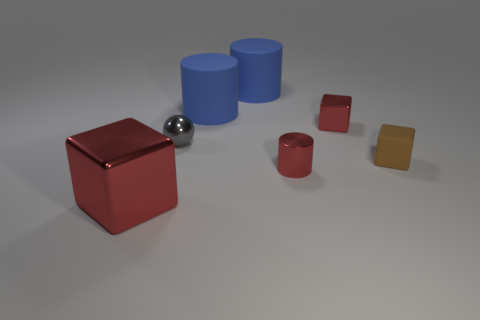Are there fewer red cubes that are in front of the tiny brown block than yellow metallic objects?
Provide a short and direct response. No. How big is the cylinder in front of the red object behind the small block in front of the tiny red metallic cube?
Provide a short and direct response. Small. Is the material of the red cylinder to the left of the matte cube the same as the small gray object?
Offer a terse response. Yes. There is a large cube that is the same color as the tiny metallic cube; what is its material?
Provide a succinct answer. Metal. Is there anything else that is the same shape as the large metallic object?
Your answer should be very brief. Yes. What number of things are brown blocks or big objects?
Keep it short and to the point. 4. What size is the brown matte thing that is the same shape as the large shiny thing?
Keep it short and to the point. Small. Is there anything else that has the same size as the brown matte block?
Your response must be concise. Yes. How many other things are there of the same color as the big shiny thing?
Your response must be concise. 2. How many blocks are big yellow things or tiny brown matte objects?
Make the answer very short. 1. 